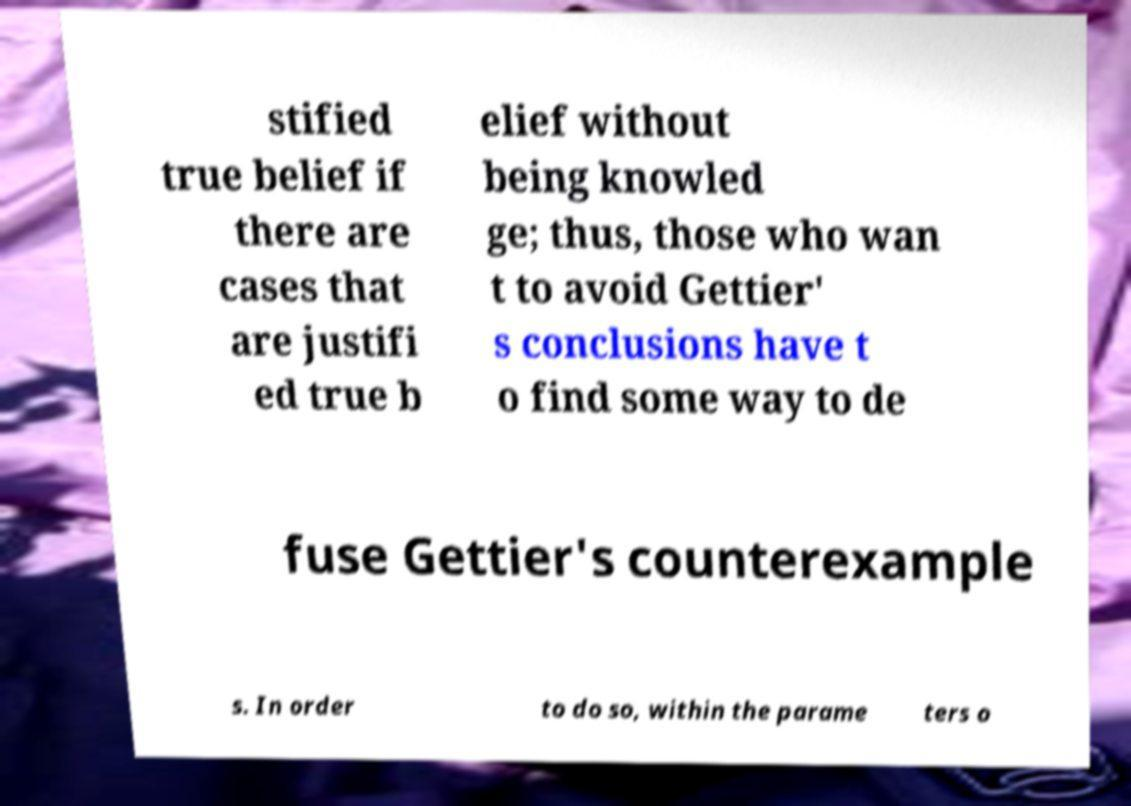I need the written content from this picture converted into text. Can you do that? stified true belief if there are cases that are justifi ed true b elief without being knowled ge; thus, those who wan t to avoid Gettier' s conclusions have t o find some way to de fuse Gettier's counterexample s. In order to do so, within the parame ters o 